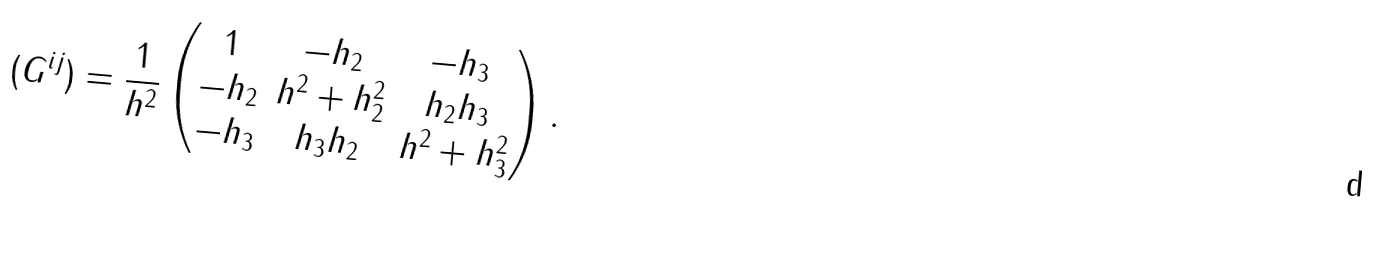Convert formula to latex. <formula><loc_0><loc_0><loc_500><loc_500>( G ^ { i j } ) = \frac { 1 } { h ^ { 2 } } \begin{pmatrix} 1 & - h _ { 2 } & - h _ { 3 } \\ - h _ { 2 } & h ^ { 2 } + h _ { 2 } ^ { 2 } & h _ { 2 } h _ { 3 } \\ - h _ { 3 } & h _ { 3 } h _ { 2 } & h ^ { 2 } + h _ { 3 } ^ { 2 } \\ \end{pmatrix} .</formula> 